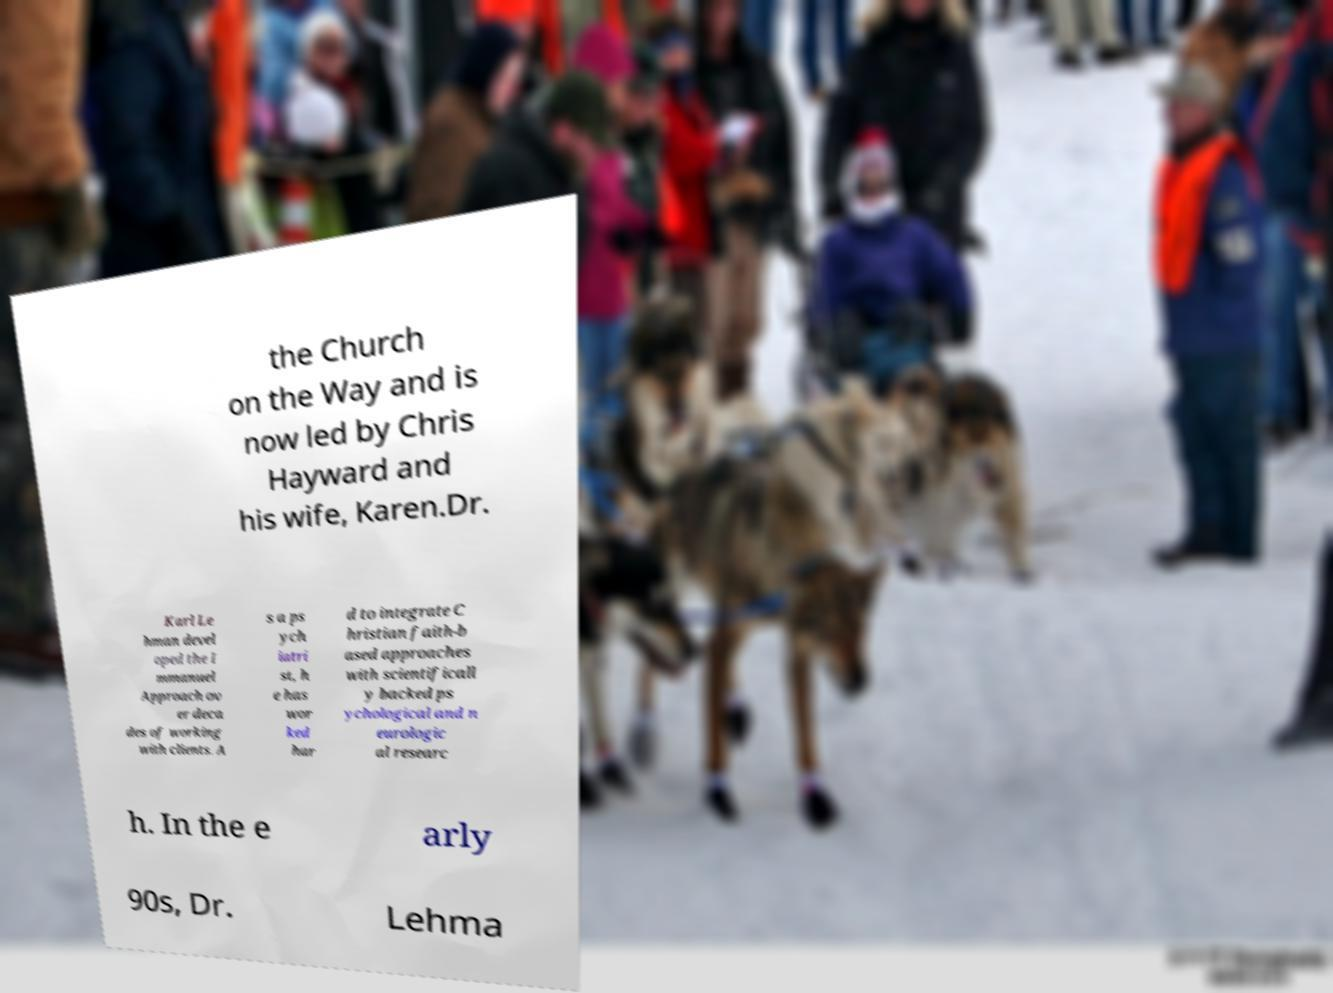Can you read and provide the text displayed in the image?This photo seems to have some interesting text. Can you extract and type it out for me? the Church on the Way and is now led by Chris Hayward and his wife, Karen.Dr. Karl Le hman devel oped the I mmanuel Approach ov er deca des of working with clients. A s a ps ych iatri st, h e has wor ked har d to integrate C hristian faith-b ased approaches with scientificall y backed ps ychological and n eurologic al researc h. In the e arly 90s, Dr. Lehma 